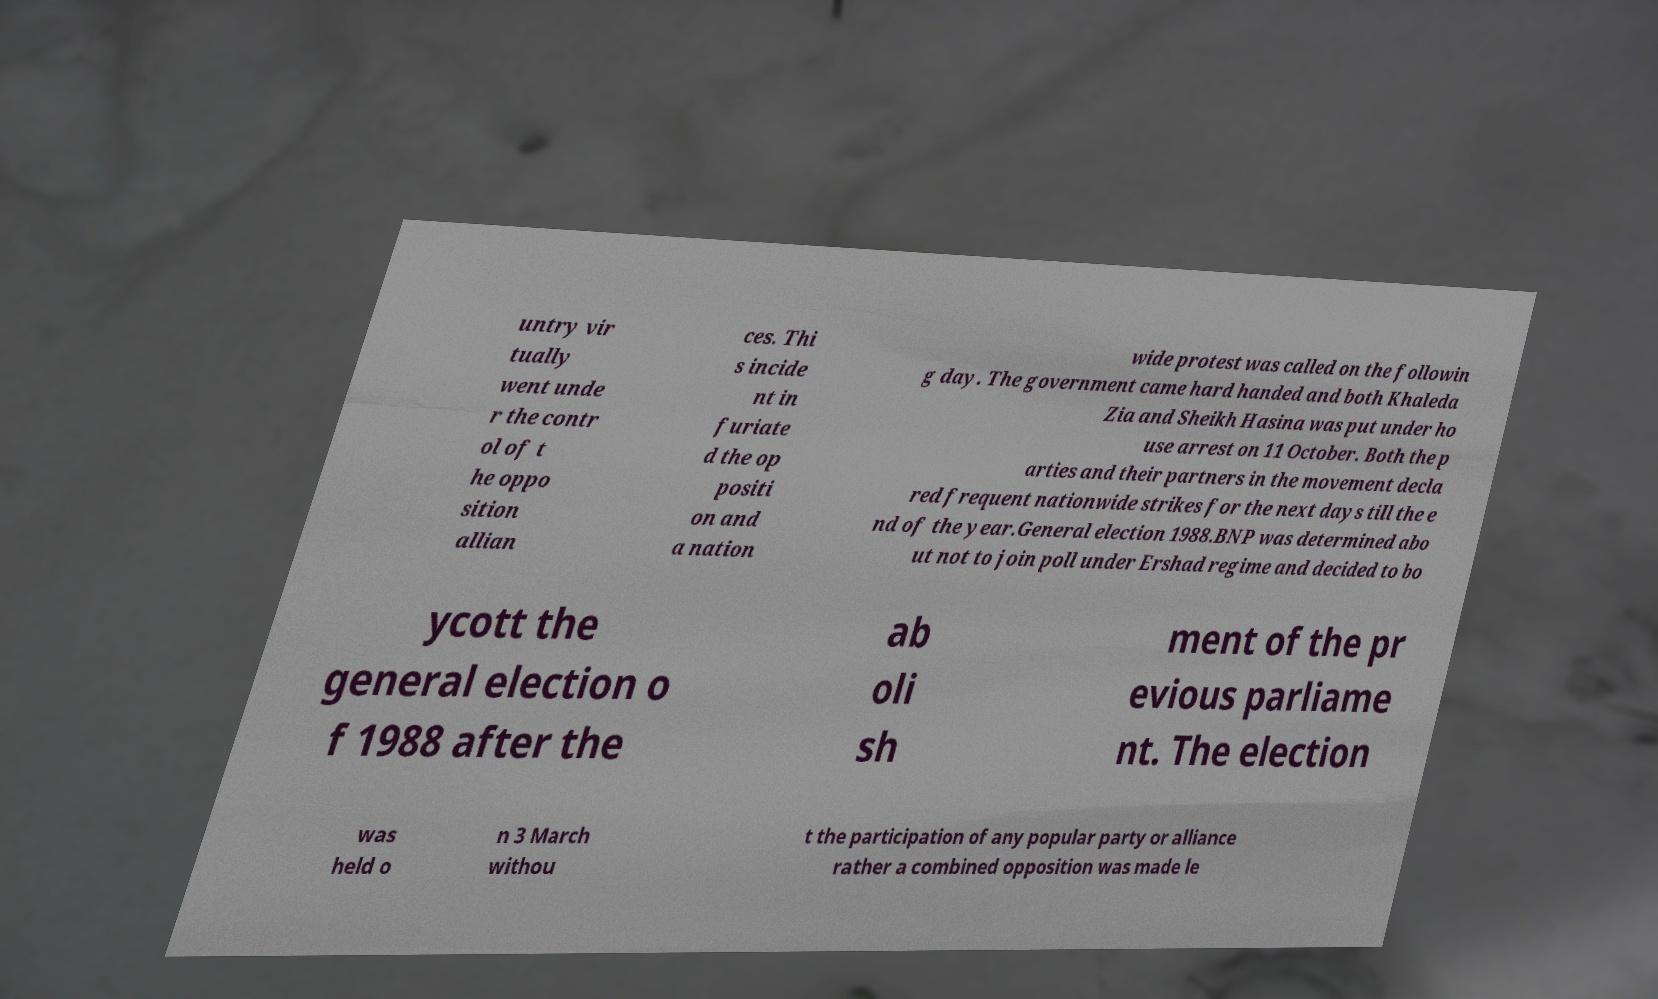I need the written content from this picture converted into text. Can you do that? untry vir tually went unde r the contr ol of t he oppo sition allian ces. Thi s incide nt in furiate d the op positi on and a nation wide protest was called on the followin g day. The government came hard handed and both Khaleda Zia and Sheikh Hasina was put under ho use arrest on 11 October. Both the p arties and their partners in the movement decla red frequent nationwide strikes for the next days till the e nd of the year.General election 1988.BNP was determined abo ut not to join poll under Ershad regime and decided to bo ycott the general election o f 1988 after the ab oli sh ment of the pr evious parliame nt. The election was held o n 3 March withou t the participation of any popular party or alliance rather a combined opposition was made le 